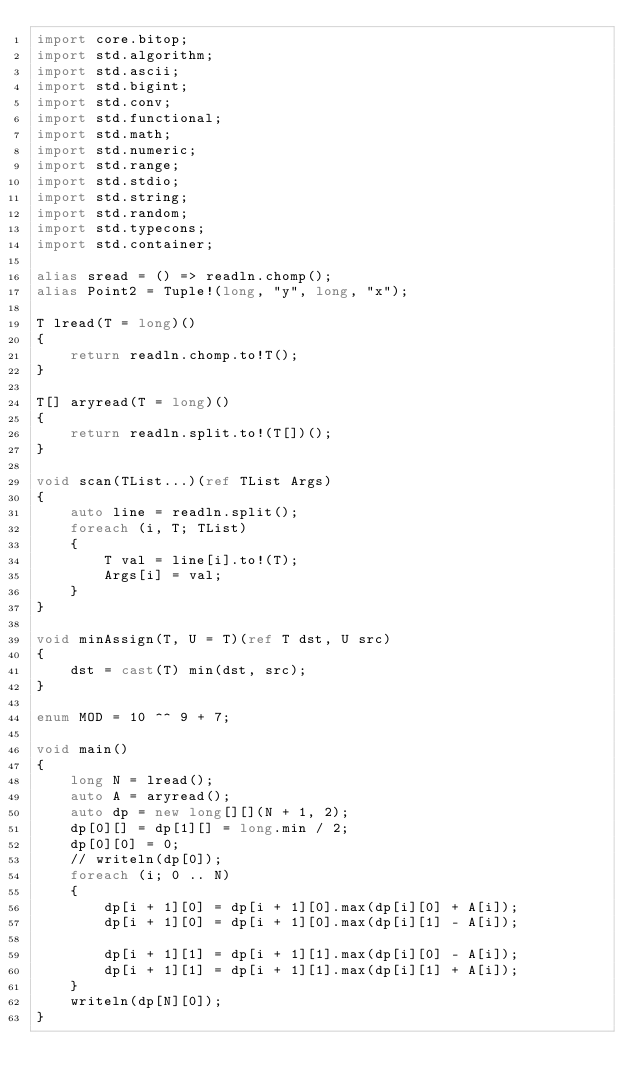<code> <loc_0><loc_0><loc_500><loc_500><_D_>import core.bitop;
import std.algorithm;
import std.ascii;
import std.bigint;
import std.conv;
import std.functional;
import std.math;
import std.numeric;
import std.range;
import std.stdio;
import std.string;
import std.random;
import std.typecons;
import std.container;

alias sread = () => readln.chomp();
alias Point2 = Tuple!(long, "y", long, "x");

T lread(T = long)()
{
    return readln.chomp.to!T();
}

T[] aryread(T = long)()
{
    return readln.split.to!(T[])();
}

void scan(TList...)(ref TList Args)
{
    auto line = readln.split();
    foreach (i, T; TList)
    {
        T val = line[i].to!(T);
        Args[i] = val;
    }
}

void minAssign(T, U = T)(ref T dst, U src)
{
    dst = cast(T) min(dst, src);
}

enum MOD = 10 ^^ 9 + 7;

void main()
{
    long N = lread();
    auto A = aryread();
    auto dp = new long[][](N + 1, 2);
    dp[0][] = dp[1][] = long.min / 2;
    dp[0][0] = 0;
    // writeln(dp[0]);
    foreach (i; 0 .. N)
    {
        dp[i + 1][0] = dp[i + 1][0].max(dp[i][0] + A[i]);
        dp[i + 1][0] = dp[i + 1][0].max(dp[i][1] - A[i]);

        dp[i + 1][1] = dp[i + 1][1].max(dp[i][0] - A[i]);
        dp[i + 1][1] = dp[i + 1][1].max(dp[i][1] + A[i]);
    }
    writeln(dp[N][0]);
}
</code> 